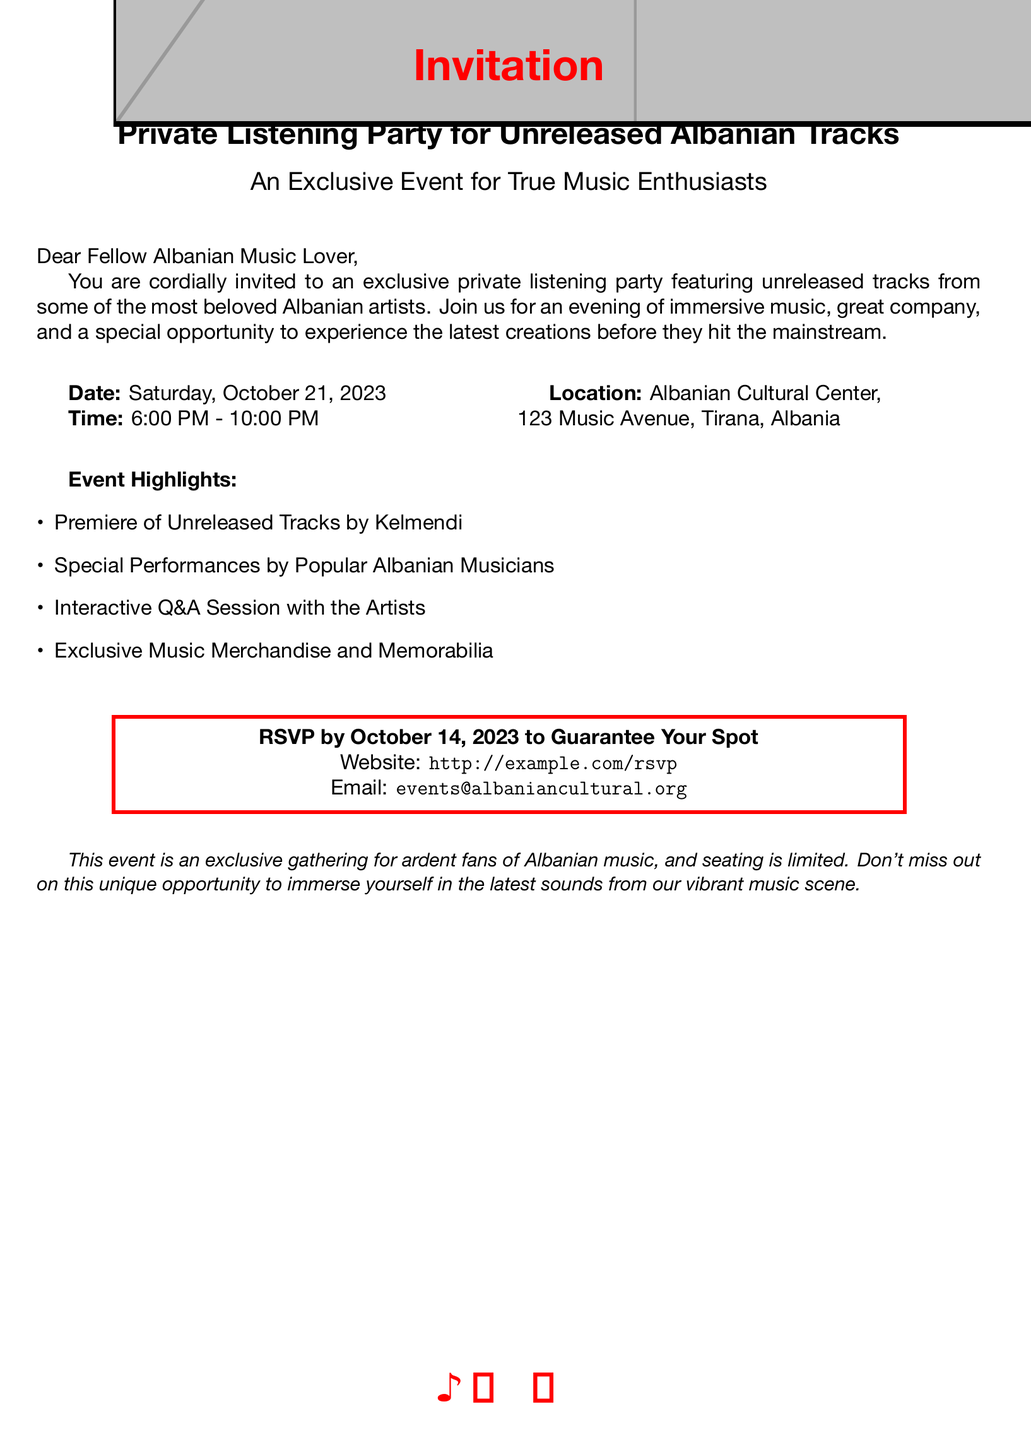What is the date of the event? The event date is explicitly mentioned in the document.
Answer: Saturday, October 21, 2023 What is the time for the listening party? The document specifies the start and end time of the event.
Answer: 6:00 PM - 10:00 PM Where is the location of the event? The location is provided clearly in the document.
Answer: Albanian Cultural Center, 123 Music Avenue, Tirana, Albania What should attendees do to guarantee their spot? The RSVP section provides instruction on what to do.
Answer: RSVP by October 14, 2023 Who will be premiering unreleased tracks? The document specifically names the individual featuring unreleased tracks.
Answer: Kelmendi What type of sessions will occur during the event? Information about interactions during the event is given in the highlights.
Answer: Q&A Session with the Artists What is the primary purpose of this invitation? The introduction describes the main goal of the gathering.
Answer: Private Listening Party for Unreleased Albanian Tracks What kind of merchandise will be available at the event? The document mentions specific offerings highlighted during the event.
Answer: Exclusive Music Merchandise and Memorabilia What color motif is used in the invitation design? A specific color is mentioned in the document that is prominent throughout the text.
Answer: Albanian red 